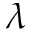Convert formula to latex. <formula><loc_0><loc_0><loc_500><loc_500>\lambda</formula> 